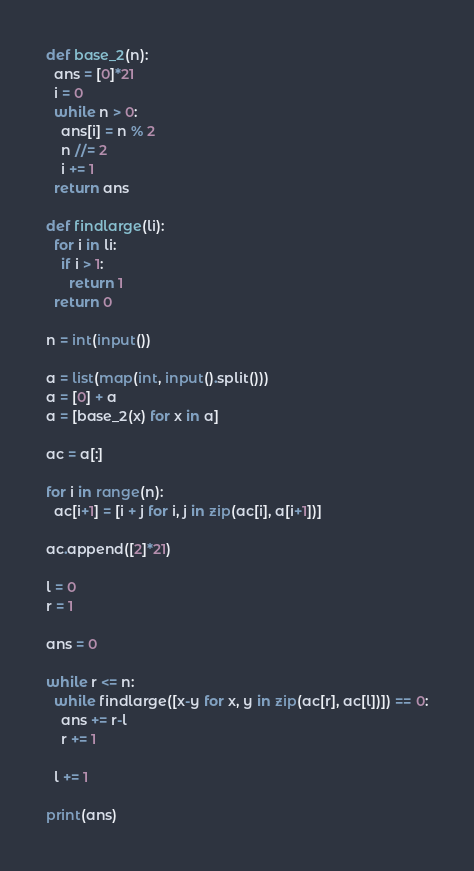Convert code to text. <code><loc_0><loc_0><loc_500><loc_500><_Python_>def base_2(n):
  ans = [0]*21
  i = 0
  while n > 0:
    ans[i] = n % 2
    n //= 2
    i += 1
  return ans

def findlarge(li):
  for i in li:
    if i > 1:
      return 1
  return 0

n = int(input())

a = list(map(int, input().split()))
a = [0] + a
a = [base_2(x) for x in a]

ac = a[:]

for i in range(n):
  ac[i+1] = [i + j for i, j in zip(ac[i], a[i+1])]

ac.append([2]*21)

l = 0
r = 1

ans = 0

while r <= n:
  while findlarge([x-y for x, y in zip(ac[r], ac[l])]) == 0:
    ans += r-l
    r += 1
    
  l += 1

print(ans)</code> 